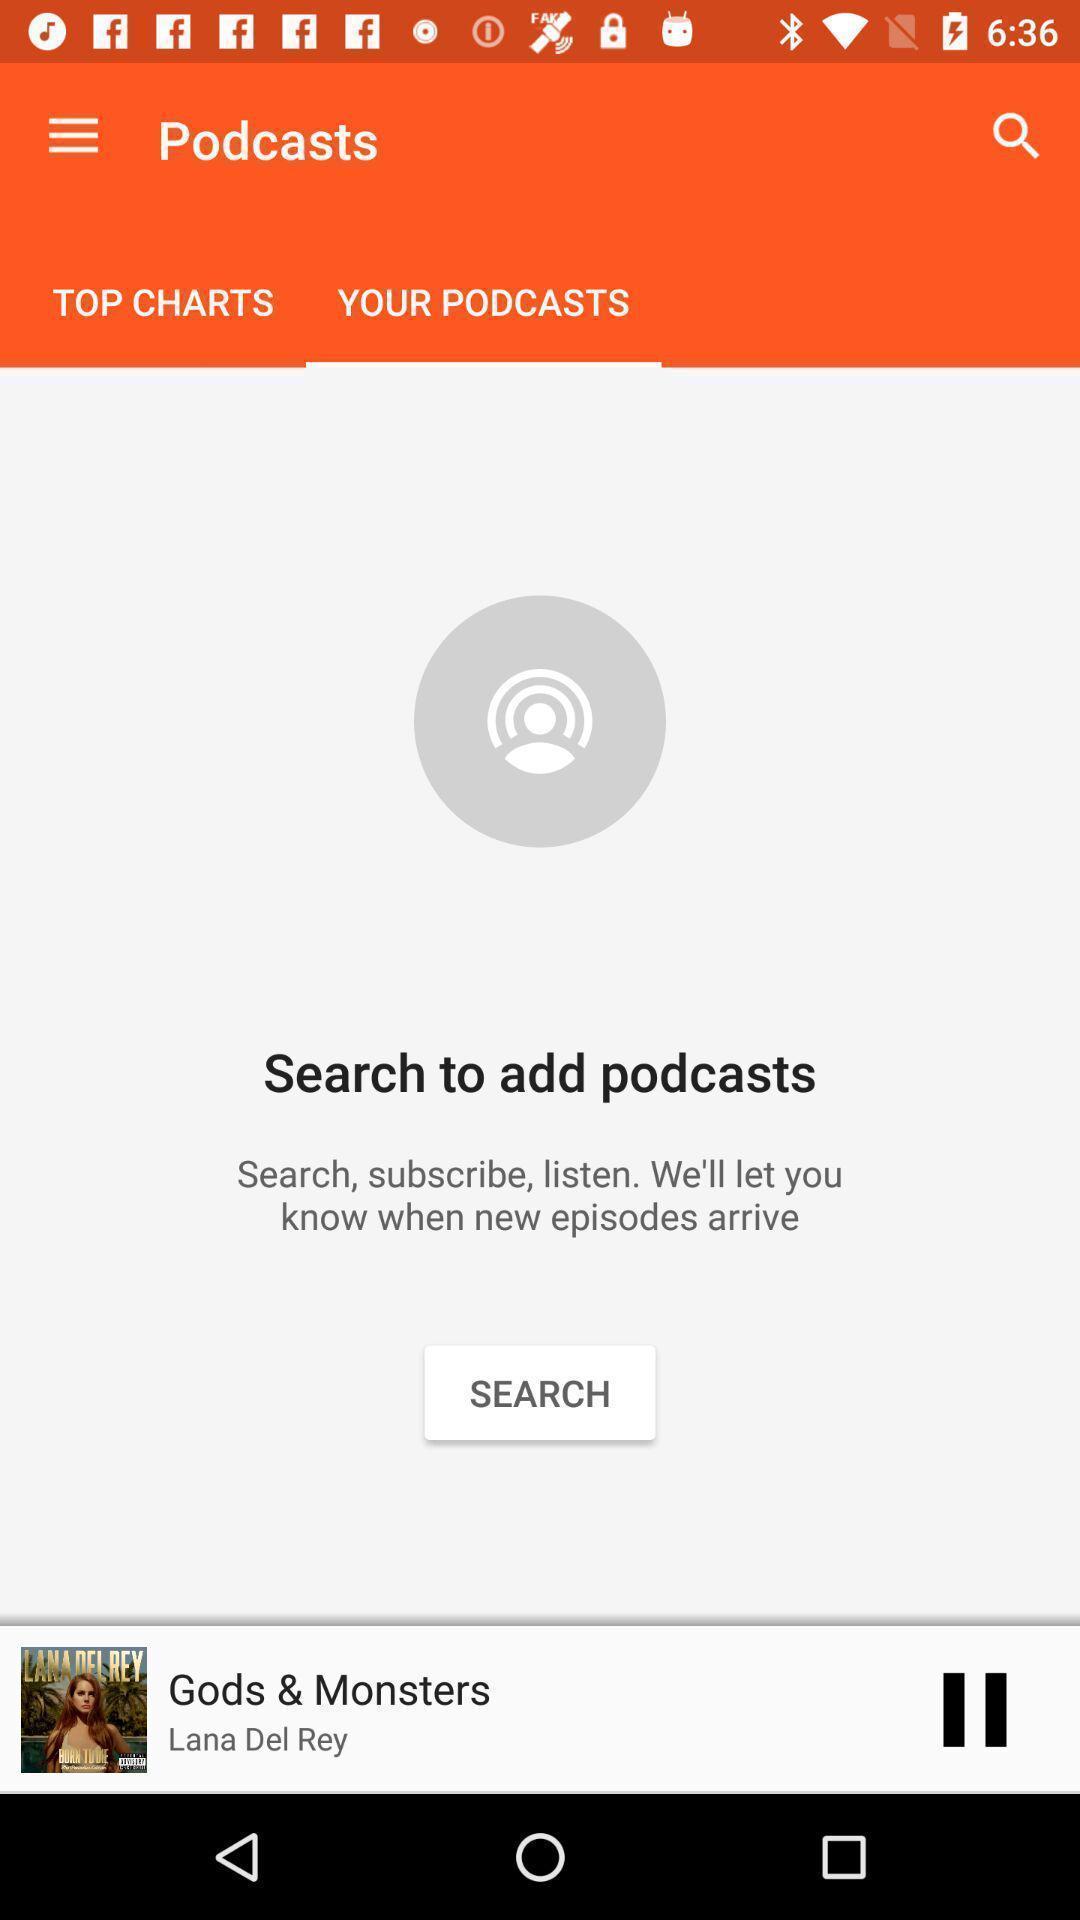Give me a summary of this screen capture. Search option to find podcasts. 